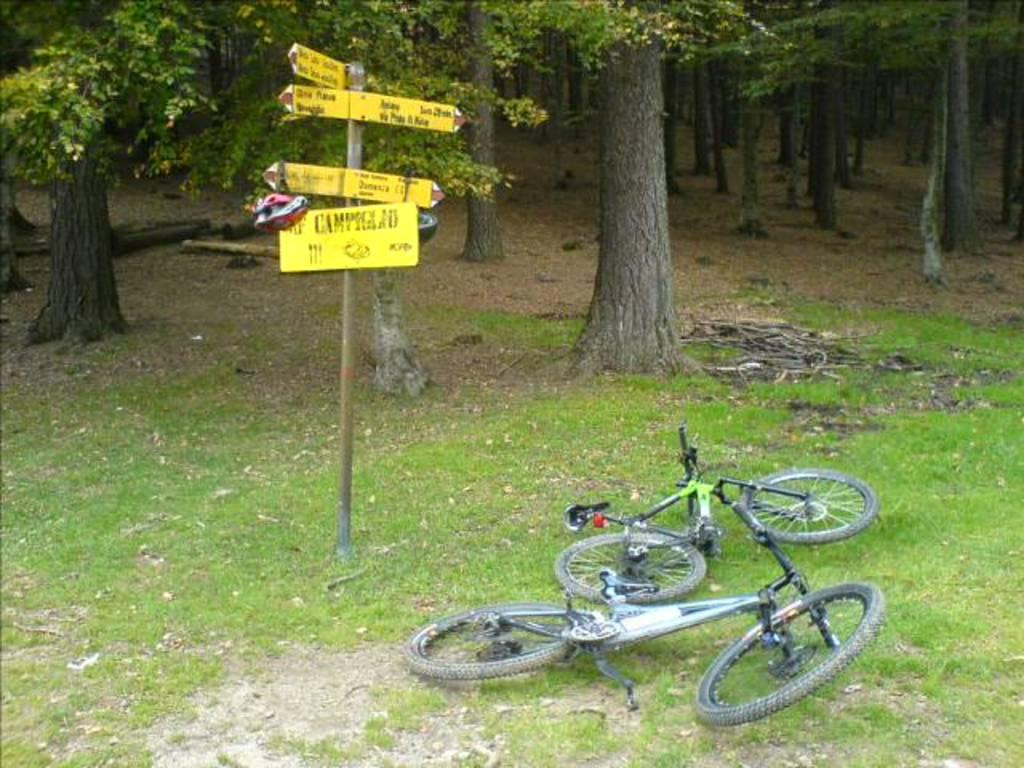What objects are on the ground in the image? There are bicycles on the ground in the image. What can be seen in the background of the image? There are boards visible in the background of the image. What type of natural elements are present in the image? There are trees in the image. Can you describe a small, thin object in the image? There is a twig in the image. What type of wooden objects are present in the image? There are logs in the image. What type of partner is visible in the image? There is no partner present in the image. What is the mass of the bicycles in the image? The mass of the bicycles cannot be determined from the image alone. 